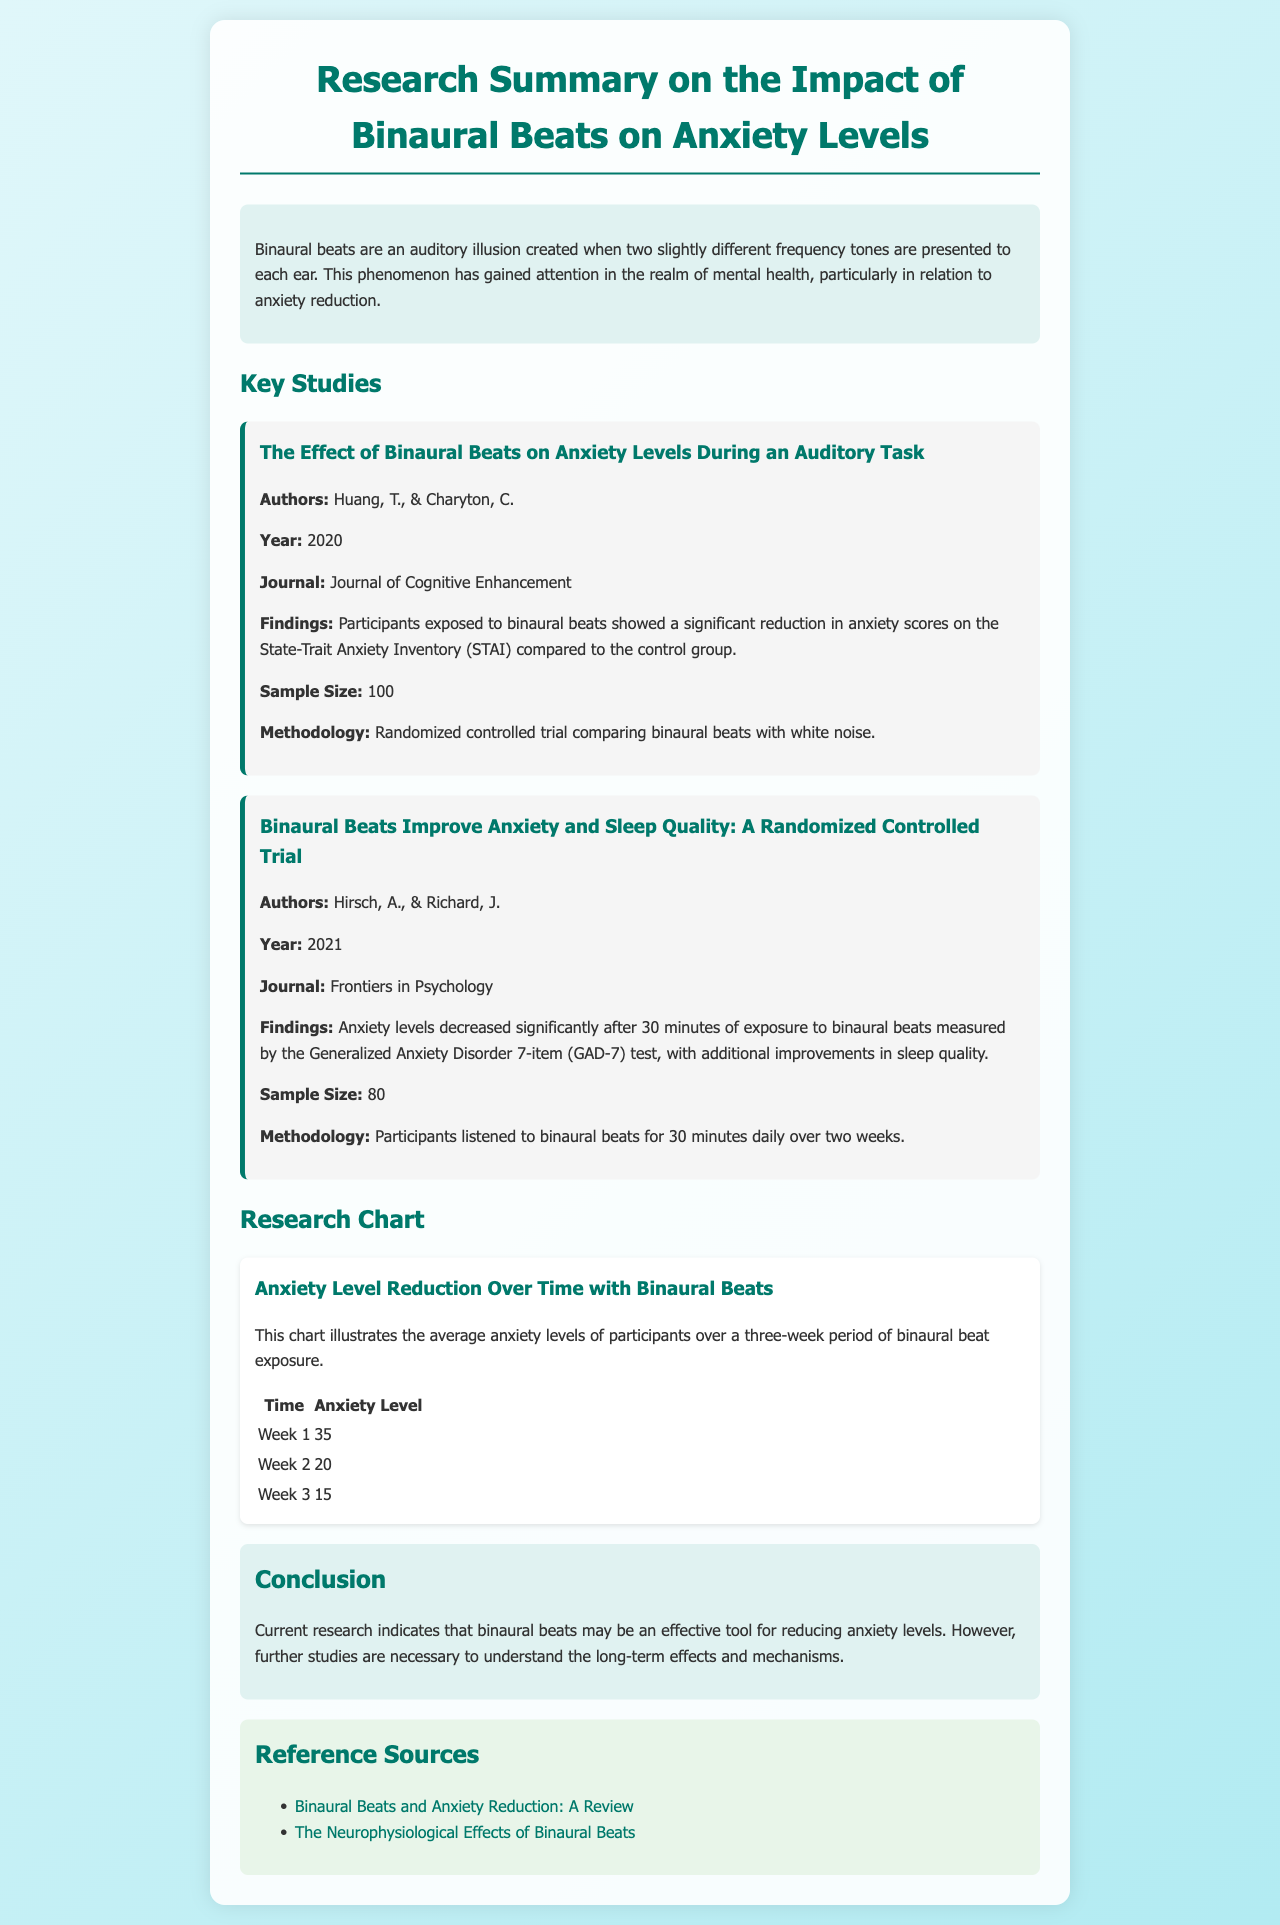What are binaural beats? Binaural beats are an auditory illusion created when two slightly different frequency tones are presented to each ear.
Answer: An auditory illusion Who are the authors of the 2020 study? The authors mentioned in the 2020 study are Huang, T., & Charyton, C.
Answer: Huang, T., & Charyton, C What was the sample size of the study by Hirsch and Richard? The sample size of the study by Hirsch and Richard is provided in the document, which states it was 80 participants.
Answer: 80 What measurement tool was used in the 2020 study? The measurement tool used in the 2020 study is the State-Trait Anxiety Inventory (STAI).
Answer: State-Trait Anxiety Inventory (STAI) How many weeks did participants listen to binaural beats in the study by Hirsch and Richard? Participants listened to binaural beats for two weeks in the study by Hirsch and Richard.
Answer: Two weeks What was the anxiety level in week 2 of the binaural beats exposure? The anxiety level in week 2 of binaural beats exposure, according to the chart, was 20.
Answer: 20 What is the main conclusion drawn from the research? The main conclusion indicates that binaural beats may be an effective tool for reducing anxiety levels.
Answer: Reducing anxiety levels What type of document is this? The document summarizes research on the impact of binaural beats on anxiety levels.
Answer: Research summary 